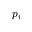Convert formula to latex. <formula><loc_0><loc_0><loc_500><loc_500>p _ { i }</formula> 